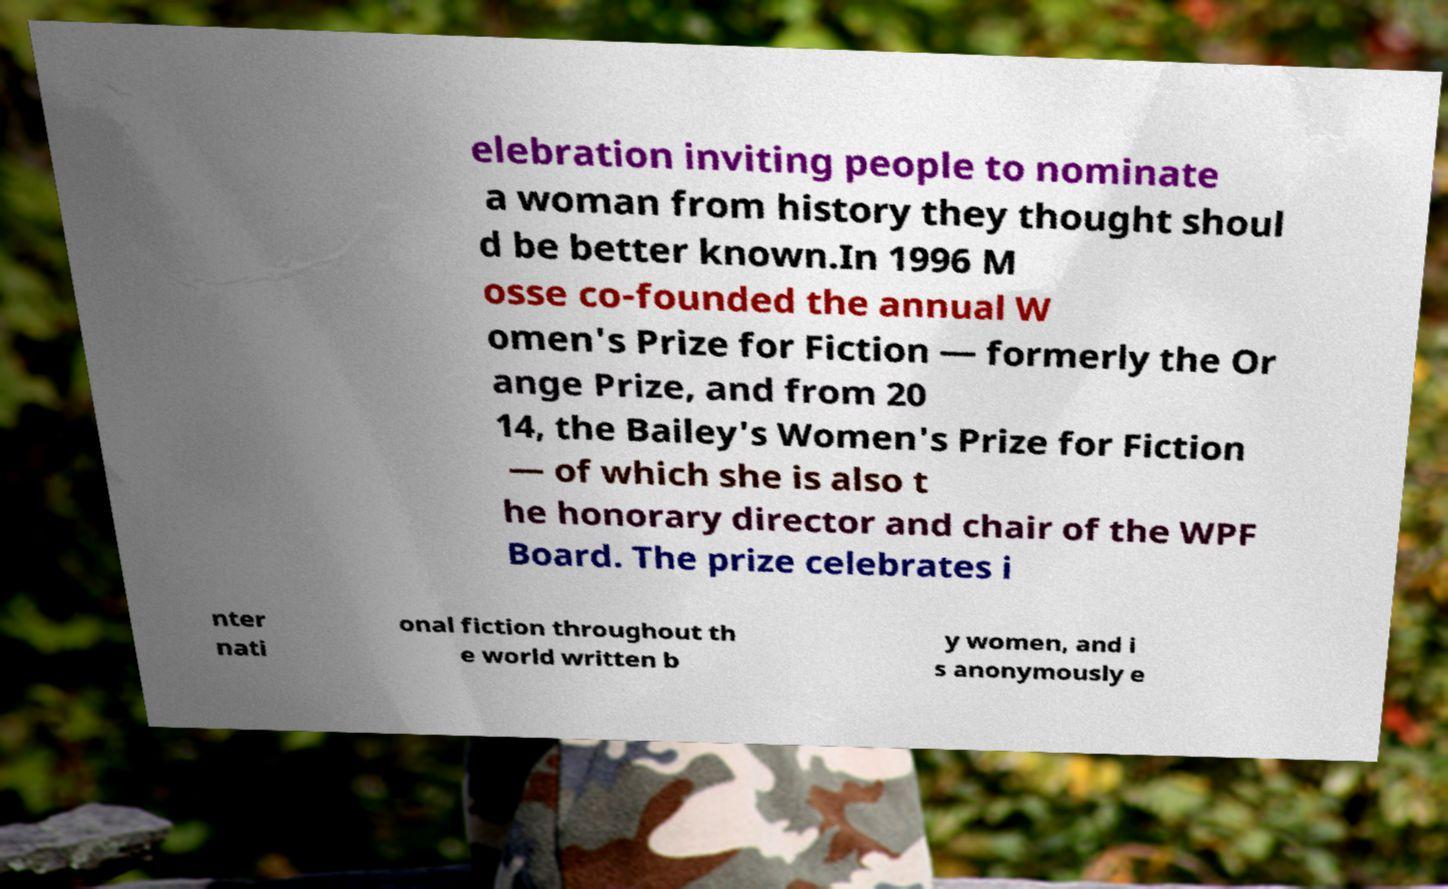Please identify and transcribe the text found in this image. elebration inviting people to nominate a woman from history they thought shoul d be better known.In 1996 M osse co-founded the annual W omen's Prize for Fiction — formerly the Or ange Prize, and from 20 14, the Bailey's Women's Prize for Fiction — of which she is also t he honorary director and chair of the WPF Board. The prize celebrates i nter nati onal fiction throughout th e world written b y women, and i s anonymously e 